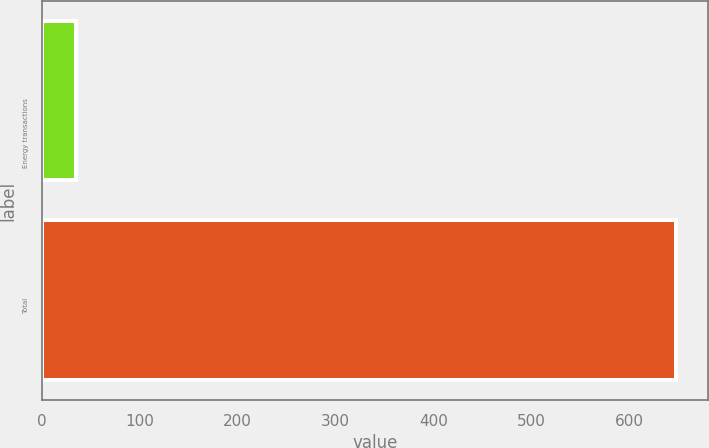<chart> <loc_0><loc_0><loc_500><loc_500><bar_chart><fcel>Energy transactions<fcel>Total<nl><fcel>35<fcel>648<nl></chart> 